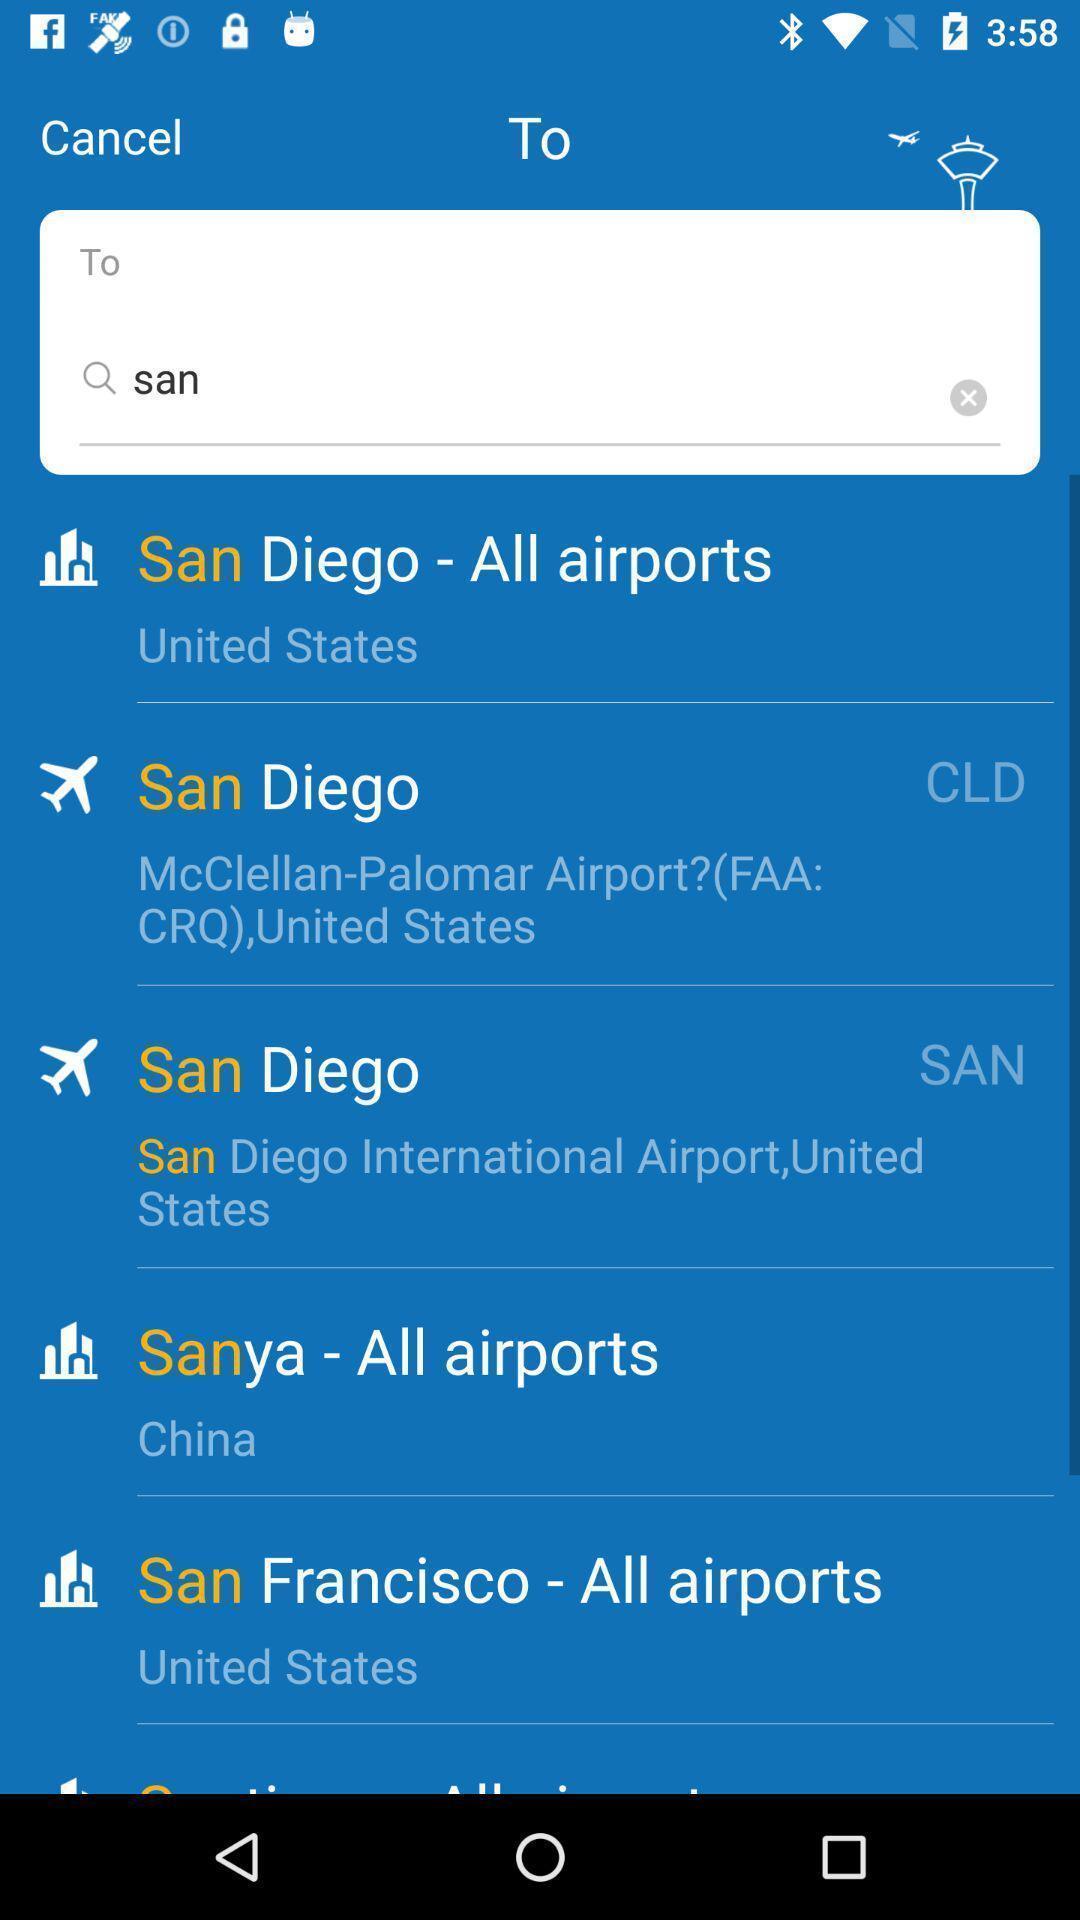What can you discern from this picture? Search page to find air ports in the travel app. 